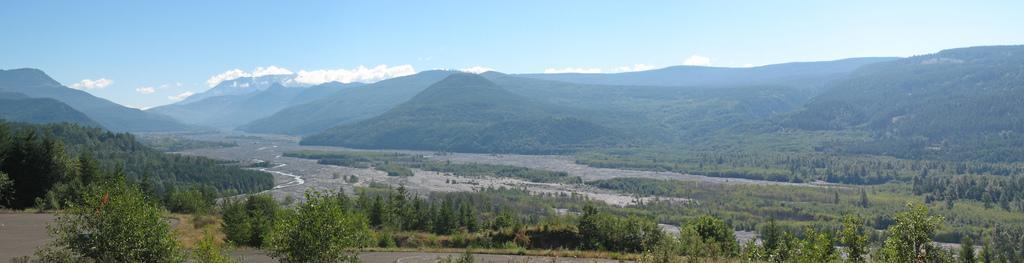How would you summarize this image in a sentence or two? In this image, we can see trees, plants, grass and roads. Background we can see hills and sky. 